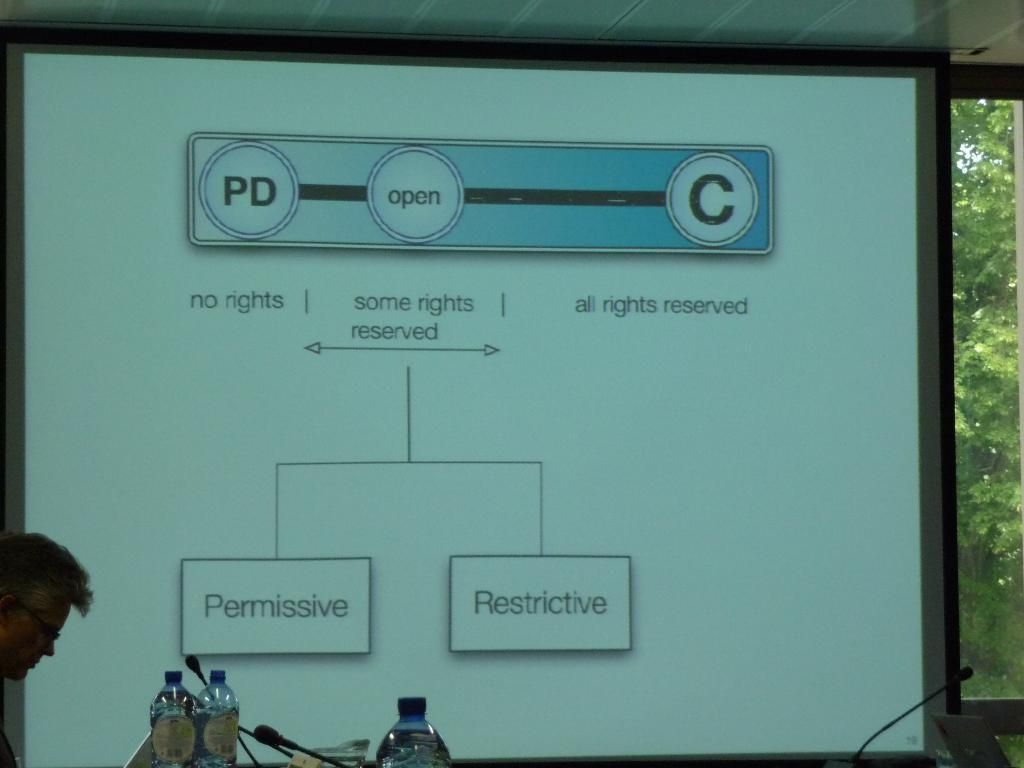How many plastic water bottles are visible in the image? There are 3 plastic water bottles in the image. What other objects can be seen in the image? There are microphones in the image. What is the person in the image doing? The person is standing and watching a laptop. What is being displayed in the image? There is a projector display in the image. What can be seen in the background of the image? Trees are visible in the background of the image. Where is the sink located in the image? There is no sink present in the image. What type of whip is being used by the person in the image? There is no whip present in the image; the person is watching a laptop. Can you tell me the age of the person's grandfather in the image? There is no grandfather present in the image. 